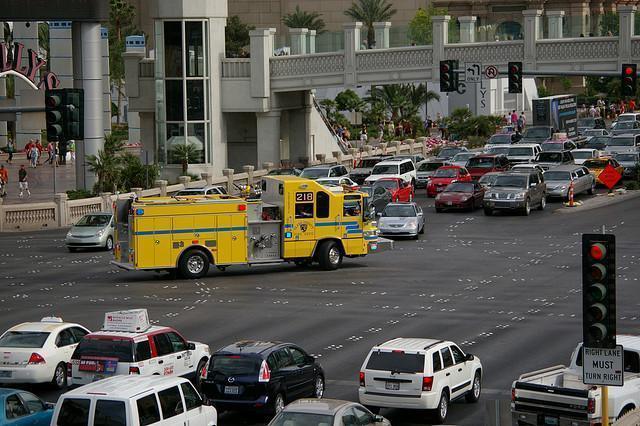Why are all the other cars letting the yellow truck go?
From the following four choices, select the correct answer to address the question.
Options: Respect, scared, emergency, no reason. Emergency. 